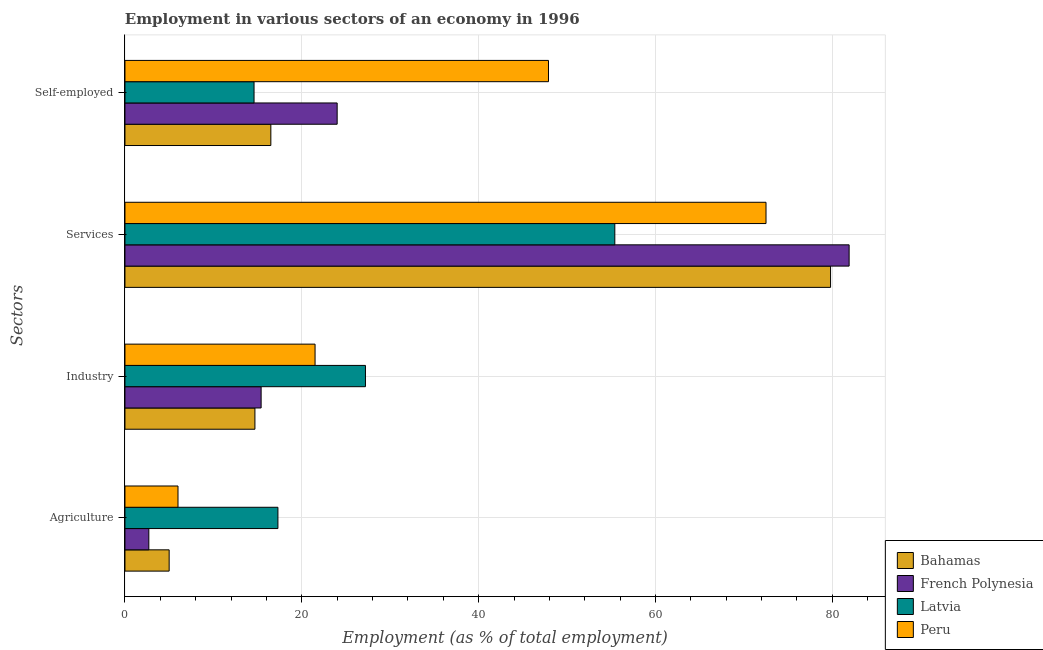How many bars are there on the 4th tick from the top?
Give a very brief answer. 4. What is the label of the 2nd group of bars from the top?
Make the answer very short. Services. What is the percentage of workers in services in Bahamas?
Your answer should be very brief. 79.8. Across all countries, what is the maximum percentage of workers in agriculture?
Your answer should be compact. 17.3. Across all countries, what is the minimum percentage of workers in services?
Your answer should be very brief. 55.4. In which country was the percentage of self employed workers maximum?
Ensure brevity in your answer.  Peru. In which country was the percentage of workers in industry minimum?
Offer a terse response. Bahamas. What is the total percentage of workers in industry in the graph?
Offer a terse response. 78.8. What is the difference between the percentage of self employed workers in Bahamas and that in Latvia?
Your response must be concise. 1.9. What is the difference between the percentage of self employed workers in Peru and the percentage of workers in industry in Bahamas?
Provide a succinct answer. 33.2. What is the average percentage of self employed workers per country?
Your answer should be compact. 25.75. What is the difference between the percentage of workers in agriculture and percentage of self employed workers in Latvia?
Your answer should be compact. 2.7. In how many countries, is the percentage of workers in services greater than 80 %?
Keep it short and to the point. 1. What is the ratio of the percentage of self employed workers in French Polynesia to that in Peru?
Offer a terse response. 0.5. Is the percentage of workers in industry in Latvia less than that in Peru?
Offer a very short reply. No. Is the difference between the percentage of workers in agriculture in Latvia and Bahamas greater than the difference between the percentage of self employed workers in Latvia and Bahamas?
Your answer should be very brief. Yes. What is the difference between the highest and the second highest percentage of self employed workers?
Your answer should be compact. 23.9. What is the difference between the highest and the lowest percentage of self employed workers?
Keep it short and to the point. 33.3. Is it the case that in every country, the sum of the percentage of workers in services and percentage of self employed workers is greater than the sum of percentage of workers in industry and percentage of workers in agriculture?
Make the answer very short. Yes. What does the 2nd bar from the top in Services represents?
Ensure brevity in your answer.  Latvia. What does the 2nd bar from the bottom in Industry represents?
Make the answer very short. French Polynesia. Are all the bars in the graph horizontal?
Your response must be concise. Yes. Does the graph contain any zero values?
Make the answer very short. No. How many legend labels are there?
Offer a terse response. 4. How are the legend labels stacked?
Your answer should be compact. Vertical. What is the title of the graph?
Provide a succinct answer. Employment in various sectors of an economy in 1996. Does "South Sudan" appear as one of the legend labels in the graph?
Provide a succinct answer. No. What is the label or title of the X-axis?
Your response must be concise. Employment (as % of total employment). What is the label or title of the Y-axis?
Your answer should be very brief. Sectors. What is the Employment (as % of total employment) of Bahamas in Agriculture?
Give a very brief answer. 5. What is the Employment (as % of total employment) in French Polynesia in Agriculture?
Keep it short and to the point. 2.7. What is the Employment (as % of total employment) of Latvia in Agriculture?
Your response must be concise. 17.3. What is the Employment (as % of total employment) of Bahamas in Industry?
Give a very brief answer. 14.7. What is the Employment (as % of total employment) in French Polynesia in Industry?
Provide a short and direct response. 15.4. What is the Employment (as % of total employment) of Latvia in Industry?
Offer a very short reply. 27.2. What is the Employment (as % of total employment) of Peru in Industry?
Offer a terse response. 21.5. What is the Employment (as % of total employment) in Bahamas in Services?
Ensure brevity in your answer.  79.8. What is the Employment (as % of total employment) in French Polynesia in Services?
Offer a terse response. 81.9. What is the Employment (as % of total employment) of Latvia in Services?
Offer a very short reply. 55.4. What is the Employment (as % of total employment) in Peru in Services?
Offer a terse response. 72.5. What is the Employment (as % of total employment) in Bahamas in Self-employed?
Offer a very short reply. 16.5. What is the Employment (as % of total employment) in French Polynesia in Self-employed?
Offer a terse response. 24. What is the Employment (as % of total employment) of Latvia in Self-employed?
Your answer should be very brief. 14.6. What is the Employment (as % of total employment) of Peru in Self-employed?
Offer a very short reply. 47.9. Across all Sectors, what is the maximum Employment (as % of total employment) of Bahamas?
Keep it short and to the point. 79.8. Across all Sectors, what is the maximum Employment (as % of total employment) in French Polynesia?
Ensure brevity in your answer.  81.9. Across all Sectors, what is the maximum Employment (as % of total employment) of Latvia?
Your response must be concise. 55.4. Across all Sectors, what is the maximum Employment (as % of total employment) of Peru?
Provide a short and direct response. 72.5. Across all Sectors, what is the minimum Employment (as % of total employment) in French Polynesia?
Give a very brief answer. 2.7. Across all Sectors, what is the minimum Employment (as % of total employment) in Latvia?
Your answer should be very brief. 14.6. Across all Sectors, what is the minimum Employment (as % of total employment) in Peru?
Make the answer very short. 6. What is the total Employment (as % of total employment) of Bahamas in the graph?
Offer a terse response. 116. What is the total Employment (as % of total employment) of French Polynesia in the graph?
Provide a short and direct response. 124. What is the total Employment (as % of total employment) of Latvia in the graph?
Keep it short and to the point. 114.5. What is the total Employment (as % of total employment) in Peru in the graph?
Your answer should be very brief. 147.9. What is the difference between the Employment (as % of total employment) of Bahamas in Agriculture and that in Industry?
Your answer should be very brief. -9.7. What is the difference between the Employment (as % of total employment) in Latvia in Agriculture and that in Industry?
Give a very brief answer. -9.9. What is the difference between the Employment (as % of total employment) in Peru in Agriculture and that in Industry?
Give a very brief answer. -15.5. What is the difference between the Employment (as % of total employment) of Bahamas in Agriculture and that in Services?
Your response must be concise. -74.8. What is the difference between the Employment (as % of total employment) in French Polynesia in Agriculture and that in Services?
Give a very brief answer. -79.2. What is the difference between the Employment (as % of total employment) in Latvia in Agriculture and that in Services?
Ensure brevity in your answer.  -38.1. What is the difference between the Employment (as % of total employment) in Peru in Agriculture and that in Services?
Offer a very short reply. -66.5. What is the difference between the Employment (as % of total employment) of Bahamas in Agriculture and that in Self-employed?
Your answer should be compact. -11.5. What is the difference between the Employment (as % of total employment) in French Polynesia in Agriculture and that in Self-employed?
Give a very brief answer. -21.3. What is the difference between the Employment (as % of total employment) of Peru in Agriculture and that in Self-employed?
Keep it short and to the point. -41.9. What is the difference between the Employment (as % of total employment) of Bahamas in Industry and that in Services?
Your answer should be very brief. -65.1. What is the difference between the Employment (as % of total employment) in French Polynesia in Industry and that in Services?
Offer a terse response. -66.5. What is the difference between the Employment (as % of total employment) of Latvia in Industry and that in Services?
Ensure brevity in your answer.  -28.2. What is the difference between the Employment (as % of total employment) in Peru in Industry and that in Services?
Provide a succinct answer. -51. What is the difference between the Employment (as % of total employment) in Bahamas in Industry and that in Self-employed?
Your answer should be very brief. -1.8. What is the difference between the Employment (as % of total employment) of Latvia in Industry and that in Self-employed?
Provide a succinct answer. 12.6. What is the difference between the Employment (as % of total employment) in Peru in Industry and that in Self-employed?
Offer a very short reply. -26.4. What is the difference between the Employment (as % of total employment) in Bahamas in Services and that in Self-employed?
Keep it short and to the point. 63.3. What is the difference between the Employment (as % of total employment) of French Polynesia in Services and that in Self-employed?
Your answer should be compact. 57.9. What is the difference between the Employment (as % of total employment) in Latvia in Services and that in Self-employed?
Your answer should be very brief. 40.8. What is the difference between the Employment (as % of total employment) of Peru in Services and that in Self-employed?
Provide a succinct answer. 24.6. What is the difference between the Employment (as % of total employment) of Bahamas in Agriculture and the Employment (as % of total employment) of Latvia in Industry?
Ensure brevity in your answer.  -22.2. What is the difference between the Employment (as % of total employment) in Bahamas in Agriculture and the Employment (as % of total employment) in Peru in Industry?
Provide a short and direct response. -16.5. What is the difference between the Employment (as % of total employment) in French Polynesia in Agriculture and the Employment (as % of total employment) in Latvia in Industry?
Give a very brief answer. -24.5. What is the difference between the Employment (as % of total employment) in French Polynesia in Agriculture and the Employment (as % of total employment) in Peru in Industry?
Provide a succinct answer. -18.8. What is the difference between the Employment (as % of total employment) in Bahamas in Agriculture and the Employment (as % of total employment) in French Polynesia in Services?
Ensure brevity in your answer.  -76.9. What is the difference between the Employment (as % of total employment) of Bahamas in Agriculture and the Employment (as % of total employment) of Latvia in Services?
Your answer should be very brief. -50.4. What is the difference between the Employment (as % of total employment) in Bahamas in Agriculture and the Employment (as % of total employment) in Peru in Services?
Provide a succinct answer. -67.5. What is the difference between the Employment (as % of total employment) of French Polynesia in Agriculture and the Employment (as % of total employment) of Latvia in Services?
Your answer should be compact. -52.7. What is the difference between the Employment (as % of total employment) of French Polynesia in Agriculture and the Employment (as % of total employment) of Peru in Services?
Keep it short and to the point. -69.8. What is the difference between the Employment (as % of total employment) of Latvia in Agriculture and the Employment (as % of total employment) of Peru in Services?
Provide a succinct answer. -55.2. What is the difference between the Employment (as % of total employment) of Bahamas in Agriculture and the Employment (as % of total employment) of French Polynesia in Self-employed?
Your response must be concise. -19. What is the difference between the Employment (as % of total employment) of Bahamas in Agriculture and the Employment (as % of total employment) of Latvia in Self-employed?
Provide a succinct answer. -9.6. What is the difference between the Employment (as % of total employment) of Bahamas in Agriculture and the Employment (as % of total employment) of Peru in Self-employed?
Your answer should be compact. -42.9. What is the difference between the Employment (as % of total employment) of French Polynesia in Agriculture and the Employment (as % of total employment) of Latvia in Self-employed?
Keep it short and to the point. -11.9. What is the difference between the Employment (as % of total employment) in French Polynesia in Agriculture and the Employment (as % of total employment) in Peru in Self-employed?
Give a very brief answer. -45.2. What is the difference between the Employment (as % of total employment) in Latvia in Agriculture and the Employment (as % of total employment) in Peru in Self-employed?
Keep it short and to the point. -30.6. What is the difference between the Employment (as % of total employment) of Bahamas in Industry and the Employment (as % of total employment) of French Polynesia in Services?
Your answer should be compact. -67.2. What is the difference between the Employment (as % of total employment) of Bahamas in Industry and the Employment (as % of total employment) of Latvia in Services?
Your answer should be compact. -40.7. What is the difference between the Employment (as % of total employment) of Bahamas in Industry and the Employment (as % of total employment) of Peru in Services?
Give a very brief answer. -57.8. What is the difference between the Employment (as % of total employment) of French Polynesia in Industry and the Employment (as % of total employment) of Peru in Services?
Offer a very short reply. -57.1. What is the difference between the Employment (as % of total employment) in Latvia in Industry and the Employment (as % of total employment) in Peru in Services?
Your answer should be very brief. -45.3. What is the difference between the Employment (as % of total employment) of Bahamas in Industry and the Employment (as % of total employment) of French Polynesia in Self-employed?
Make the answer very short. -9.3. What is the difference between the Employment (as % of total employment) in Bahamas in Industry and the Employment (as % of total employment) in Peru in Self-employed?
Make the answer very short. -33.2. What is the difference between the Employment (as % of total employment) in French Polynesia in Industry and the Employment (as % of total employment) in Latvia in Self-employed?
Provide a short and direct response. 0.8. What is the difference between the Employment (as % of total employment) of French Polynesia in Industry and the Employment (as % of total employment) of Peru in Self-employed?
Offer a very short reply. -32.5. What is the difference between the Employment (as % of total employment) in Latvia in Industry and the Employment (as % of total employment) in Peru in Self-employed?
Ensure brevity in your answer.  -20.7. What is the difference between the Employment (as % of total employment) of Bahamas in Services and the Employment (as % of total employment) of French Polynesia in Self-employed?
Your response must be concise. 55.8. What is the difference between the Employment (as % of total employment) in Bahamas in Services and the Employment (as % of total employment) in Latvia in Self-employed?
Your answer should be compact. 65.2. What is the difference between the Employment (as % of total employment) in Bahamas in Services and the Employment (as % of total employment) in Peru in Self-employed?
Offer a terse response. 31.9. What is the difference between the Employment (as % of total employment) of French Polynesia in Services and the Employment (as % of total employment) of Latvia in Self-employed?
Offer a very short reply. 67.3. What is the difference between the Employment (as % of total employment) of French Polynesia in Services and the Employment (as % of total employment) of Peru in Self-employed?
Make the answer very short. 34. What is the difference between the Employment (as % of total employment) of Latvia in Services and the Employment (as % of total employment) of Peru in Self-employed?
Ensure brevity in your answer.  7.5. What is the average Employment (as % of total employment) of French Polynesia per Sectors?
Make the answer very short. 31. What is the average Employment (as % of total employment) in Latvia per Sectors?
Your answer should be compact. 28.62. What is the average Employment (as % of total employment) in Peru per Sectors?
Provide a succinct answer. 36.98. What is the difference between the Employment (as % of total employment) of Bahamas and Employment (as % of total employment) of Latvia in Agriculture?
Provide a succinct answer. -12.3. What is the difference between the Employment (as % of total employment) of Bahamas and Employment (as % of total employment) of Peru in Agriculture?
Your answer should be compact. -1. What is the difference between the Employment (as % of total employment) in French Polynesia and Employment (as % of total employment) in Latvia in Agriculture?
Offer a very short reply. -14.6. What is the difference between the Employment (as % of total employment) in French Polynesia and Employment (as % of total employment) in Peru in Agriculture?
Give a very brief answer. -3.3. What is the difference between the Employment (as % of total employment) of Bahamas and Employment (as % of total employment) of French Polynesia in Industry?
Your answer should be very brief. -0.7. What is the difference between the Employment (as % of total employment) in French Polynesia and Employment (as % of total employment) in Peru in Industry?
Provide a succinct answer. -6.1. What is the difference between the Employment (as % of total employment) in Latvia and Employment (as % of total employment) in Peru in Industry?
Your answer should be very brief. 5.7. What is the difference between the Employment (as % of total employment) in Bahamas and Employment (as % of total employment) in Latvia in Services?
Offer a terse response. 24.4. What is the difference between the Employment (as % of total employment) in Latvia and Employment (as % of total employment) in Peru in Services?
Make the answer very short. -17.1. What is the difference between the Employment (as % of total employment) of Bahamas and Employment (as % of total employment) of Peru in Self-employed?
Your response must be concise. -31.4. What is the difference between the Employment (as % of total employment) in French Polynesia and Employment (as % of total employment) in Latvia in Self-employed?
Provide a short and direct response. 9.4. What is the difference between the Employment (as % of total employment) of French Polynesia and Employment (as % of total employment) of Peru in Self-employed?
Ensure brevity in your answer.  -23.9. What is the difference between the Employment (as % of total employment) of Latvia and Employment (as % of total employment) of Peru in Self-employed?
Keep it short and to the point. -33.3. What is the ratio of the Employment (as % of total employment) in Bahamas in Agriculture to that in Industry?
Make the answer very short. 0.34. What is the ratio of the Employment (as % of total employment) in French Polynesia in Agriculture to that in Industry?
Your response must be concise. 0.18. What is the ratio of the Employment (as % of total employment) in Latvia in Agriculture to that in Industry?
Offer a very short reply. 0.64. What is the ratio of the Employment (as % of total employment) in Peru in Agriculture to that in Industry?
Your answer should be very brief. 0.28. What is the ratio of the Employment (as % of total employment) of Bahamas in Agriculture to that in Services?
Your response must be concise. 0.06. What is the ratio of the Employment (as % of total employment) of French Polynesia in Agriculture to that in Services?
Your response must be concise. 0.03. What is the ratio of the Employment (as % of total employment) in Latvia in Agriculture to that in Services?
Make the answer very short. 0.31. What is the ratio of the Employment (as % of total employment) in Peru in Agriculture to that in Services?
Make the answer very short. 0.08. What is the ratio of the Employment (as % of total employment) of Bahamas in Agriculture to that in Self-employed?
Offer a terse response. 0.3. What is the ratio of the Employment (as % of total employment) in French Polynesia in Agriculture to that in Self-employed?
Give a very brief answer. 0.11. What is the ratio of the Employment (as % of total employment) of Latvia in Agriculture to that in Self-employed?
Keep it short and to the point. 1.18. What is the ratio of the Employment (as % of total employment) in Peru in Agriculture to that in Self-employed?
Your answer should be compact. 0.13. What is the ratio of the Employment (as % of total employment) in Bahamas in Industry to that in Services?
Provide a succinct answer. 0.18. What is the ratio of the Employment (as % of total employment) of French Polynesia in Industry to that in Services?
Offer a very short reply. 0.19. What is the ratio of the Employment (as % of total employment) in Latvia in Industry to that in Services?
Provide a succinct answer. 0.49. What is the ratio of the Employment (as % of total employment) in Peru in Industry to that in Services?
Make the answer very short. 0.3. What is the ratio of the Employment (as % of total employment) in Bahamas in Industry to that in Self-employed?
Ensure brevity in your answer.  0.89. What is the ratio of the Employment (as % of total employment) in French Polynesia in Industry to that in Self-employed?
Provide a succinct answer. 0.64. What is the ratio of the Employment (as % of total employment) of Latvia in Industry to that in Self-employed?
Your response must be concise. 1.86. What is the ratio of the Employment (as % of total employment) in Peru in Industry to that in Self-employed?
Offer a very short reply. 0.45. What is the ratio of the Employment (as % of total employment) in Bahamas in Services to that in Self-employed?
Provide a succinct answer. 4.84. What is the ratio of the Employment (as % of total employment) of French Polynesia in Services to that in Self-employed?
Your answer should be very brief. 3.41. What is the ratio of the Employment (as % of total employment) in Latvia in Services to that in Self-employed?
Keep it short and to the point. 3.79. What is the ratio of the Employment (as % of total employment) in Peru in Services to that in Self-employed?
Your answer should be compact. 1.51. What is the difference between the highest and the second highest Employment (as % of total employment) of Bahamas?
Ensure brevity in your answer.  63.3. What is the difference between the highest and the second highest Employment (as % of total employment) of French Polynesia?
Offer a very short reply. 57.9. What is the difference between the highest and the second highest Employment (as % of total employment) in Latvia?
Make the answer very short. 28.2. What is the difference between the highest and the second highest Employment (as % of total employment) in Peru?
Your answer should be very brief. 24.6. What is the difference between the highest and the lowest Employment (as % of total employment) of Bahamas?
Provide a short and direct response. 74.8. What is the difference between the highest and the lowest Employment (as % of total employment) in French Polynesia?
Offer a very short reply. 79.2. What is the difference between the highest and the lowest Employment (as % of total employment) of Latvia?
Your answer should be compact. 40.8. What is the difference between the highest and the lowest Employment (as % of total employment) in Peru?
Your answer should be compact. 66.5. 